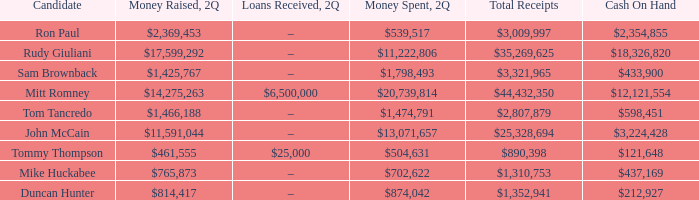Name the loans received for 2Q having total receipts of $25,328,694 –. 